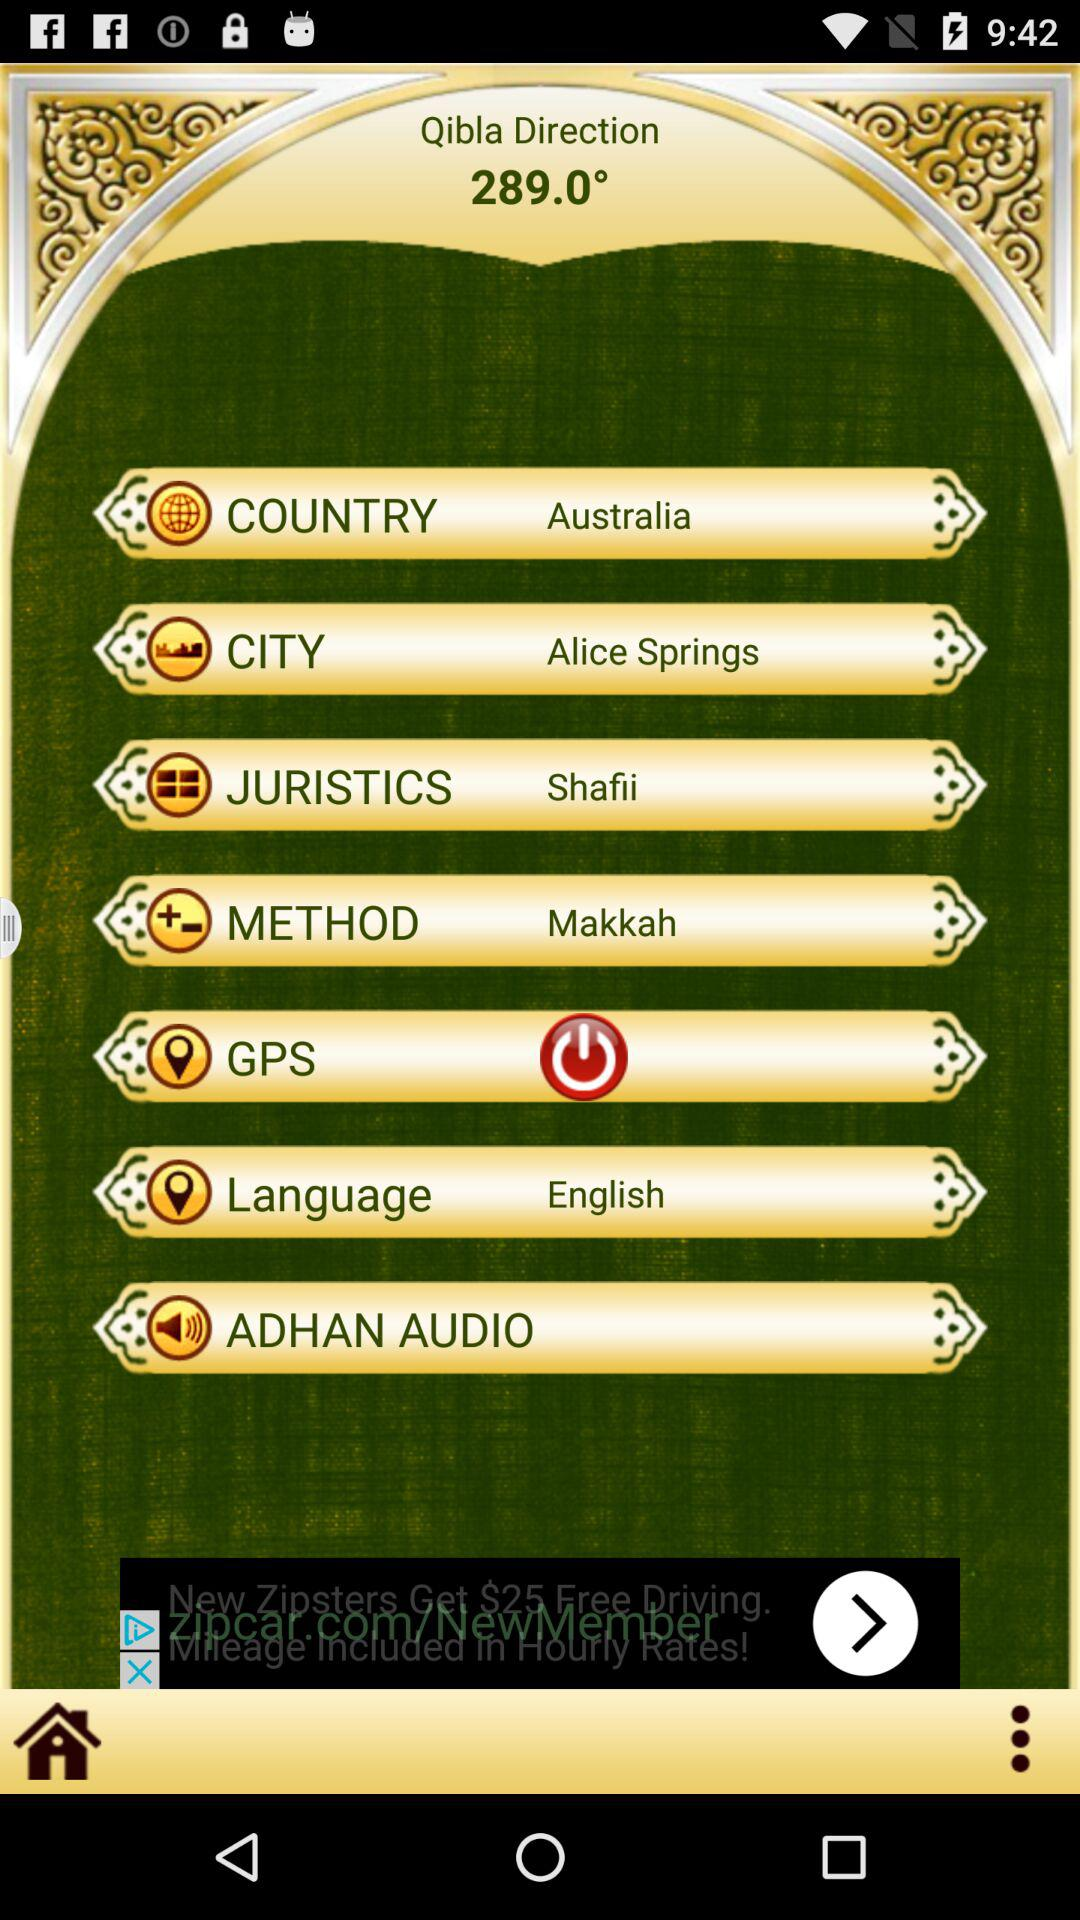What is the selected method? The selected method is "Makkah". 